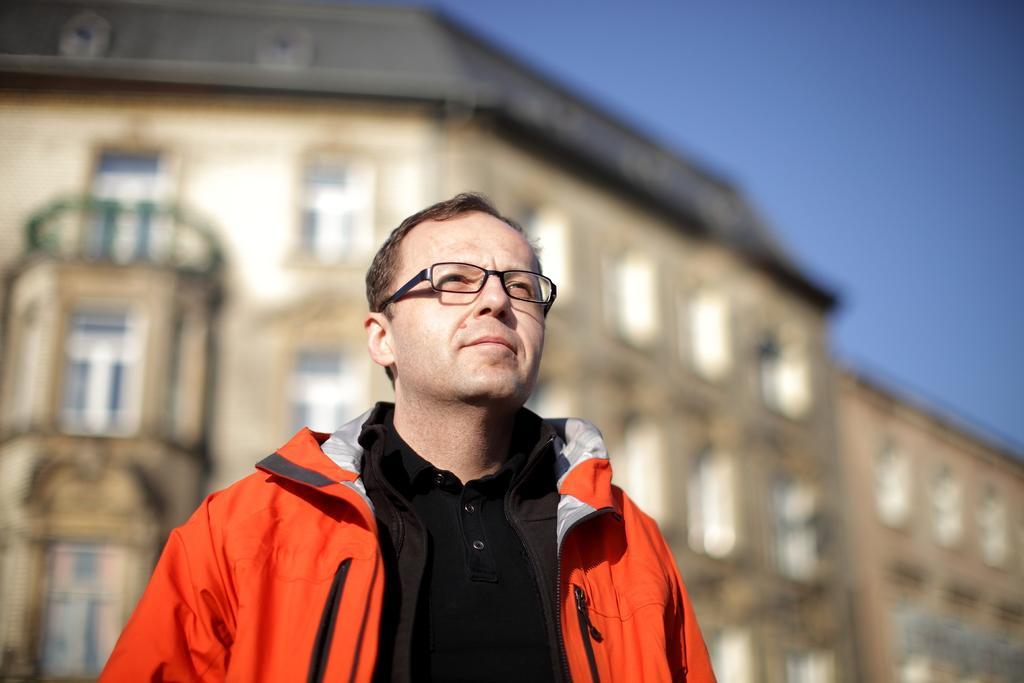Could you give a brief overview of what you see in this image? In this image I can see the person standing and the person is wearing black and orange color dress. In the background I can see few buildings, windows and the sky is in blue color. 